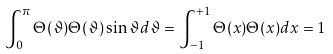<formula> <loc_0><loc_0><loc_500><loc_500>\int _ { 0 } ^ { \pi } \Theta ( \vartheta ) \Theta ( \vartheta ) \sin \vartheta d \vartheta = \int _ { - 1 } ^ { + 1 } \Theta ( x ) \Theta ( x ) d x = 1</formula> 